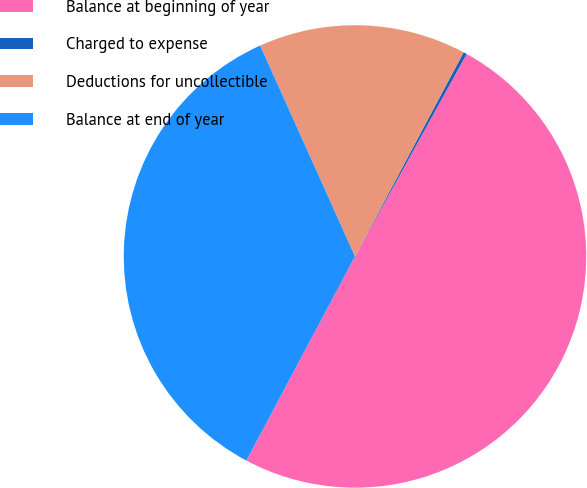Convert chart to OTSL. <chart><loc_0><loc_0><loc_500><loc_500><pie_chart><fcel>Balance at beginning of year<fcel>Charged to expense<fcel>Deductions for uncollectible<fcel>Balance at end of year<nl><fcel>49.76%<fcel>0.24%<fcel>14.51%<fcel>35.49%<nl></chart> 